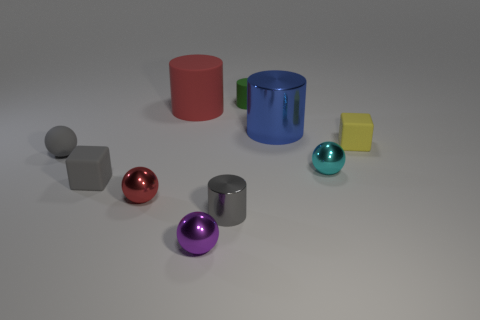There is a tiny cylinder that is the same color as the matte ball; what is it made of?
Provide a succinct answer. Metal. What is the shape of the small matte thing behind the small matte cube that is on the right side of the large rubber object on the left side of the tiny purple object?
Your answer should be compact. Cylinder. Are there more tiny red balls than cyan metallic cylinders?
Provide a short and direct response. Yes. Are there any big yellow matte cylinders?
Give a very brief answer. No. What number of things are big cylinders that are behind the tiny red metal ball or tiny metal objects that are in front of the tiny red sphere?
Your answer should be compact. 4. Do the matte sphere and the large matte cylinder have the same color?
Offer a terse response. No. Is the number of brown cylinders less than the number of blue objects?
Provide a succinct answer. Yes. Are there any large objects left of the purple ball?
Give a very brief answer. Yes. Are the big red thing and the gray cylinder made of the same material?
Ensure brevity in your answer.  No. What color is the other tiny object that is the same shape as the tiny yellow object?
Offer a very short reply. Gray. 